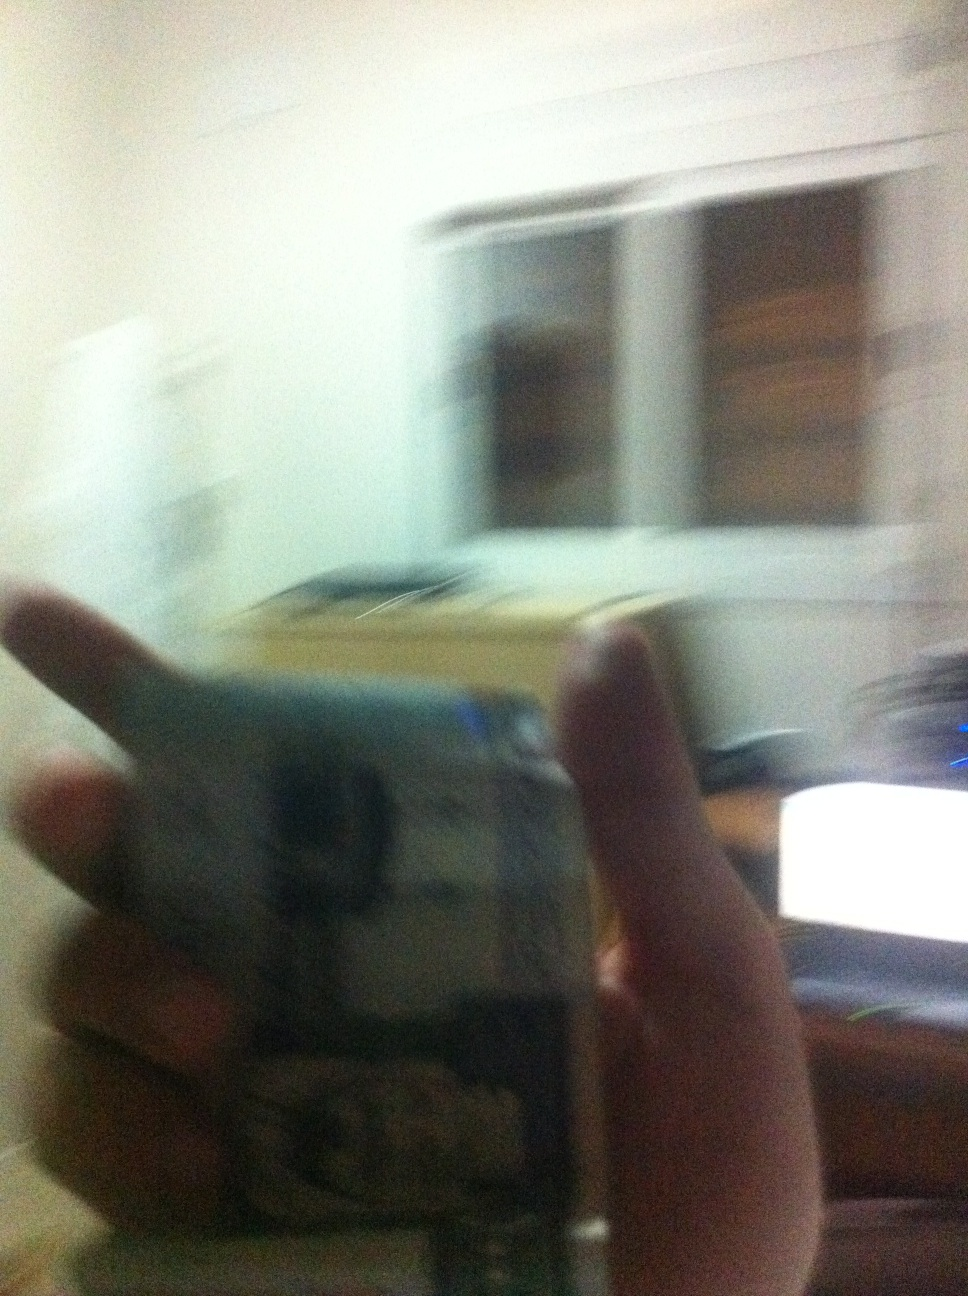Can you create a dramatic scene based on the image? In the dimly lit room, a sense of urgency hung in the air. The person, holding a stack of blurred bills, glanced anxiously at the unmarked package on the desk. It was a race against time. The documents on the computer revealed a secret plan, and every second counted as they tried to piece together the clues before it was too late. 